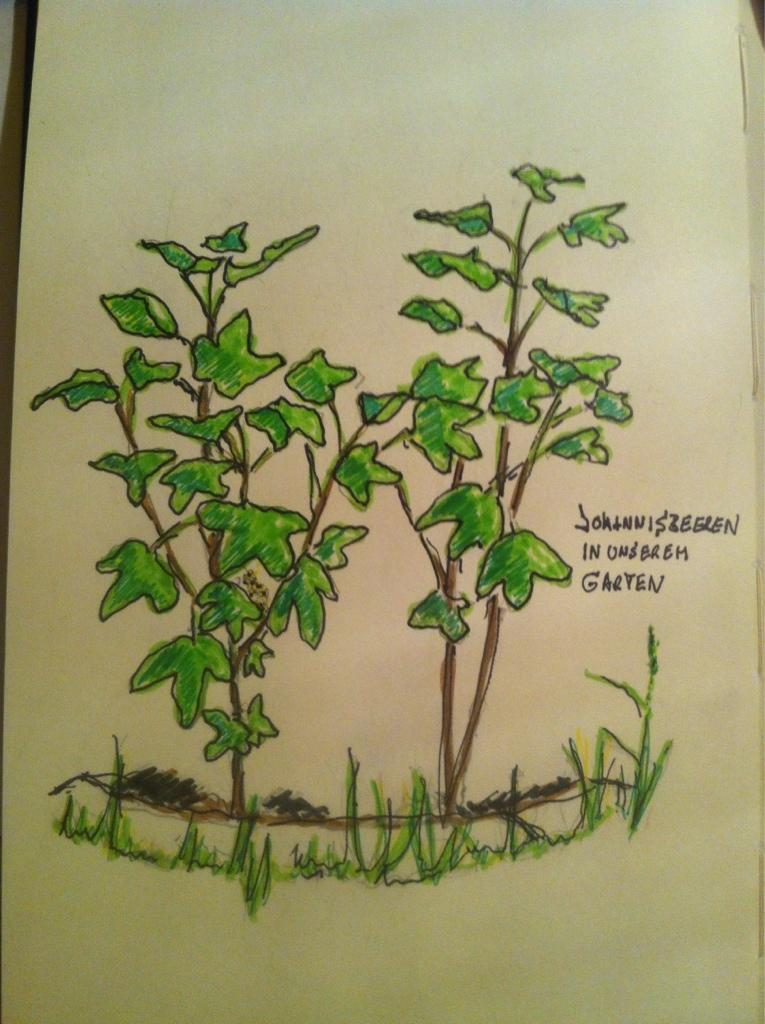Please provide a concise description of this image. In this picture we can see painting of plants, grass and text on a paper. 